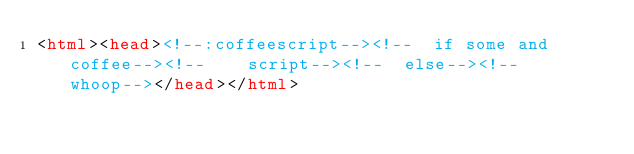Convert code to text. <code><loc_0><loc_0><loc_500><loc_500><_HTML_><html><head><!--:coffeescript--><!--  if some and coffee--><!--    script--><!--  else--><!--    whoop--></head></html></code> 